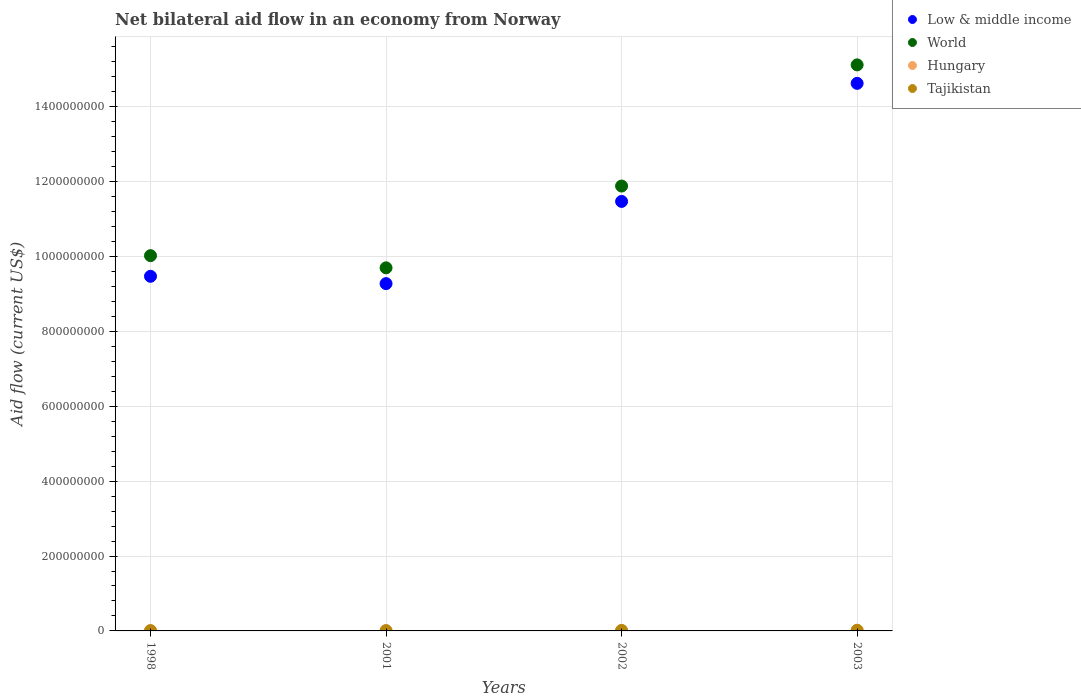How many different coloured dotlines are there?
Offer a terse response. 4. Is the number of dotlines equal to the number of legend labels?
Provide a short and direct response. Yes. Across all years, what is the maximum net bilateral aid flow in World?
Ensure brevity in your answer.  1.51e+09. Across all years, what is the minimum net bilateral aid flow in Low & middle income?
Give a very brief answer. 9.28e+08. In which year was the net bilateral aid flow in World maximum?
Provide a short and direct response. 2003. In which year was the net bilateral aid flow in Low & middle income minimum?
Your answer should be very brief. 2001. What is the total net bilateral aid flow in Low & middle income in the graph?
Ensure brevity in your answer.  4.48e+09. What is the difference between the net bilateral aid flow in Tajikistan in 2002 and that in 2003?
Keep it short and to the point. -4.90e+05. What is the difference between the net bilateral aid flow in Hungary in 1998 and the net bilateral aid flow in Low & middle income in 2001?
Provide a short and direct response. -9.27e+08. What is the average net bilateral aid flow in Tajikistan per year?
Give a very brief answer. 1.22e+06. In the year 2001, what is the difference between the net bilateral aid flow in World and net bilateral aid flow in Hungary?
Provide a short and direct response. 9.70e+08. What is the ratio of the net bilateral aid flow in Hungary in 1998 to that in 2003?
Provide a succinct answer. 0.49. Is the difference between the net bilateral aid flow in World in 1998 and 2003 greater than the difference between the net bilateral aid flow in Hungary in 1998 and 2003?
Your response must be concise. No. What is the difference between the highest and the lowest net bilateral aid flow in World?
Provide a short and direct response. 5.42e+08. Is it the case that in every year, the sum of the net bilateral aid flow in Hungary and net bilateral aid flow in Tajikistan  is greater than the sum of net bilateral aid flow in Low & middle income and net bilateral aid flow in World?
Offer a terse response. Yes. Is it the case that in every year, the sum of the net bilateral aid flow in Hungary and net bilateral aid flow in World  is greater than the net bilateral aid flow in Low & middle income?
Make the answer very short. Yes. Does the net bilateral aid flow in Tajikistan monotonically increase over the years?
Keep it short and to the point. No. How many years are there in the graph?
Make the answer very short. 4. Does the graph contain any zero values?
Ensure brevity in your answer.  No. Does the graph contain grids?
Ensure brevity in your answer.  Yes. Where does the legend appear in the graph?
Make the answer very short. Top right. How many legend labels are there?
Provide a short and direct response. 4. How are the legend labels stacked?
Your response must be concise. Vertical. What is the title of the graph?
Your answer should be compact. Net bilateral aid flow in an economy from Norway. Does "China" appear as one of the legend labels in the graph?
Ensure brevity in your answer.  No. What is the label or title of the Y-axis?
Provide a succinct answer. Aid flow (current US$). What is the Aid flow (current US$) in Low & middle income in 1998?
Provide a succinct answer. 9.47e+08. What is the Aid flow (current US$) of World in 1998?
Provide a succinct answer. 1.00e+09. What is the Aid flow (current US$) in Hungary in 1998?
Offer a very short reply. 1.70e+05. What is the Aid flow (current US$) in Tajikistan in 1998?
Provide a succinct answer. 8.30e+05. What is the Aid flow (current US$) of Low & middle income in 2001?
Ensure brevity in your answer.  9.28e+08. What is the Aid flow (current US$) of World in 2001?
Provide a short and direct response. 9.70e+08. What is the Aid flow (current US$) of Hungary in 2001?
Make the answer very short. 8.00e+04. What is the Aid flow (current US$) of Tajikistan in 2001?
Provide a succinct answer. 8.30e+05. What is the Aid flow (current US$) of Low & middle income in 2002?
Provide a succinct answer. 1.15e+09. What is the Aid flow (current US$) in World in 2002?
Offer a terse response. 1.19e+09. What is the Aid flow (current US$) of Hungary in 2002?
Provide a short and direct response. 2.80e+05. What is the Aid flow (current US$) in Tajikistan in 2002?
Your answer should be very brief. 1.36e+06. What is the Aid flow (current US$) of Low & middle income in 2003?
Provide a succinct answer. 1.46e+09. What is the Aid flow (current US$) of World in 2003?
Offer a very short reply. 1.51e+09. What is the Aid flow (current US$) in Tajikistan in 2003?
Ensure brevity in your answer.  1.85e+06. Across all years, what is the maximum Aid flow (current US$) in Low & middle income?
Give a very brief answer. 1.46e+09. Across all years, what is the maximum Aid flow (current US$) of World?
Your answer should be very brief. 1.51e+09. Across all years, what is the maximum Aid flow (current US$) in Tajikistan?
Provide a succinct answer. 1.85e+06. Across all years, what is the minimum Aid flow (current US$) of Low & middle income?
Offer a very short reply. 9.28e+08. Across all years, what is the minimum Aid flow (current US$) in World?
Offer a terse response. 9.70e+08. Across all years, what is the minimum Aid flow (current US$) in Tajikistan?
Your answer should be compact. 8.30e+05. What is the total Aid flow (current US$) of Low & middle income in the graph?
Offer a very short reply. 4.48e+09. What is the total Aid flow (current US$) in World in the graph?
Provide a succinct answer. 4.67e+09. What is the total Aid flow (current US$) in Hungary in the graph?
Give a very brief answer. 8.80e+05. What is the total Aid flow (current US$) in Tajikistan in the graph?
Ensure brevity in your answer.  4.87e+06. What is the difference between the Aid flow (current US$) in Low & middle income in 1998 and that in 2001?
Give a very brief answer. 1.95e+07. What is the difference between the Aid flow (current US$) of World in 1998 and that in 2001?
Your answer should be very brief. 3.25e+07. What is the difference between the Aid flow (current US$) in Hungary in 1998 and that in 2001?
Your answer should be very brief. 9.00e+04. What is the difference between the Aid flow (current US$) in Tajikistan in 1998 and that in 2001?
Your answer should be very brief. 0. What is the difference between the Aid flow (current US$) in Low & middle income in 1998 and that in 2002?
Offer a terse response. -2.00e+08. What is the difference between the Aid flow (current US$) in World in 1998 and that in 2002?
Ensure brevity in your answer.  -1.86e+08. What is the difference between the Aid flow (current US$) of Tajikistan in 1998 and that in 2002?
Make the answer very short. -5.30e+05. What is the difference between the Aid flow (current US$) in Low & middle income in 1998 and that in 2003?
Your response must be concise. -5.15e+08. What is the difference between the Aid flow (current US$) of World in 1998 and that in 2003?
Give a very brief answer. -5.10e+08. What is the difference between the Aid flow (current US$) in Hungary in 1998 and that in 2003?
Offer a terse response. -1.80e+05. What is the difference between the Aid flow (current US$) in Tajikistan in 1998 and that in 2003?
Offer a very short reply. -1.02e+06. What is the difference between the Aid flow (current US$) of Low & middle income in 2001 and that in 2002?
Your answer should be compact. -2.20e+08. What is the difference between the Aid flow (current US$) in World in 2001 and that in 2002?
Offer a very short reply. -2.18e+08. What is the difference between the Aid flow (current US$) of Tajikistan in 2001 and that in 2002?
Your answer should be compact. -5.30e+05. What is the difference between the Aid flow (current US$) in Low & middle income in 2001 and that in 2003?
Your answer should be very brief. -5.35e+08. What is the difference between the Aid flow (current US$) in World in 2001 and that in 2003?
Offer a terse response. -5.42e+08. What is the difference between the Aid flow (current US$) of Hungary in 2001 and that in 2003?
Your answer should be compact. -2.70e+05. What is the difference between the Aid flow (current US$) of Tajikistan in 2001 and that in 2003?
Your response must be concise. -1.02e+06. What is the difference between the Aid flow (current US$) of Low & middle income in 2002 and that in 2003?
Provide a succinct answer. -3.15e+08. What is the difference between the Aid flow (current US$) of World in 2002 and that in 2003?
Offer a very short reply. -3.24e+08. What is the difference between the Aid flow (current US$) of Tajikistan in 2002 and that in 2003?
Your response must be concise. -4.90e+05. What is the difference between the Aid flow (current US$) in Low & middle income in 1998 and the Aid flow (current US$) in World in 2001?
Your answer should be very brief. -2.26e+07. What is the difference between the Aid flow (current US$) of Low & middle income in 1998 and the Aid flow (current US$) of Hungary in 2001?
Keep it short and to the point. 9.47e+08. What is the difference between the Aid flow (current US$) in Low & middle income in 1998 and the Aid flow (current US$) in Tajikistan in 2001?
Keep it short and to the point. 9.46e+08. What is the difference between the Aid flow (current US$) of World in 1998 and the Aid flow (current US$) of Hungary in 2001?
Provide a short and direct response. 1.00e+09. What is the difference between the Aid flow (current US$) in World in 1998 and the Aid flow (current US$) in Tajikistan in 2001?
Your answer should be compact. 1.00e+09. What is the difference between the Aid flow (current US$) of Hungary in 1998 and the Aid flow (current US$) of Tajikistan in 2001?
Your response must be concise. -6.60e+05. What is the difference between the Aid flow (current US$) of Low & middle income in 1998 and the Aid flow (current US$) of World in 2002?
Offer a very short reply. -2.41e+08. What is the difference between the Aid flow (current US$) in Low & middle income in 1998 and the Aid flow (current US$) in Hungary in 2002?
Give a very brief answer. 9.47e+08. What is the difference between the Aid flow (current US$) in Low & middle income in 1998 and the Aid flow (current US$) in Tajikistan in 2002?
Provide a short and direct response. 9.46e+08. What is the difference between the Aid flow (current US$) of World in 1998 and the Aid flow (current US$) of Hungary in 2002?
Your response must be concise. 1.00e+09. What is the difference between the Aid flow (current US$) in World in 1998 and the Aid flow (current US$) in Tajikistan in 2002?
Your response must be concise. 1.00e+09. What is the difference between the Aid flow (current US$) of Hungary in 1998 and the Aid flow (current US$) of Tajikistan in 2002?
Make the answer very short. -1.19e+06. What is the difference between the Aid flow (current US$) in Low & middle income in 1998 and the Aid flow (current US$) in World in 2003?
Offer a very short reply. -5.65e+08. What is the difference between the Aid flow (current US$) in Low & middle income in 1998 and the Aid flow (current US$) in Hungary in 2003?
Offer a very short reply. 9.47e+08. What is the difference between the Aid flow (current US$) in Low & middle income in 1998 and the Aid flow (current US$) in Tajikistan in 2003?
Provide a succinct answer. 9.45e+08. What is the difference between the Aid flow (current US$) in World in 1998 and the Aid flow (current US$) in Hungary in 2003?
Make the answer very short. 1.00e+09. What is the difference between the Aid flow (current US$) of World in 1998 and the Aid flow (current US$) of Tajikistan in 2003?
Make the answer very short. 1.00e+09. What is the difference between the Aid flow (current US$) in Hungary in 1998 and the Aid flow (current US$) in Tajikistan in 2003?
Your answer should be very brief. -1.68e+06. What is the difference between the Aid flow (current US$) of Low & middle income in 2001 and the Aid flow (current US$) of World in 2002?
Offer a very short reply. -2.61e+08. What is the difference between the Aid flow (current US$) in Low & middle income in 2001 and the Aid flow (current US$) in Hungary in 2002?
Give a very brief answer. 9.27e+08. What is the difference between the Aid flow (current US$) of Low & middle income in 2001 and the Aid flow (current US$) of Tajikistan in 2002?
Ensure brevity in your answer.  9.26e+08. What is the difference between the Aid flow (current US$) in World in 2001 and the Aid flow (current US$) in Hungary in 2002?
Give a very brief answer. 9.70e+08. What is the difference between the Aid flow (current US$) in World in 2001 and the Aid flow (current US$) in Tajikistan in 2002?
Provide a short and direct response. 9.68e+08. What is the difference between the Aid flow (current US$) in Hungary in 2001 and the Aid flow (current US$) in Tajikistan in 2002?
Provide a short and direct response. -1.28e+06. What is the difference between the Aid flow (current US$) in Low & middle income in 2001 and the Aid flow (current US$) in World in 2003?
Give a very brief answer. -5.84e+08. What is the difference between the Aid flow (current US$) of Low & middle income in 2001 and the Aid flow (current US$) of Hungary in 2003?
Your answer should be very brief. 9.27e+08. What is the difference between the Aid flow (current US$) in Low & middle income in 2001 and the Aid flow (current US$) in Tajikistan in 2003?
Ensure brevity in your answer.  9.26e+08. What is the difference between the Aid flow (current US$) of World in 2001 and the Aid flow (current US$) of Hungary in 2003?
Offer a very short reply. 9.69e+08. What is the difference between the Aid flow (current US$) of World in 2001 and the Aid flow (current US$) of Tajikistan in 2003?
Make the answer very short. 9.68e+08. What is the difference between the Aid flow (current US$) of Hungary in 2001 and the Aid flow (current US$) of Tajikistan in 2003?
Your answer should be compact. -1.77e+06. What is the difference between the Aid flow (current US$) of Low & middle income in 2002 and the Aid flow (current US$) of World in 2003?
Make the answer very short. -3.65e+08. What is the difference between the Aid flow (current US$) of Low & middle income in 2002 and the Aid flow (current US$) of Hungary in 2003?
Make the answer very short. 1.15e+09. What is the difference between the Aid flow (current US$) of Low & middle income in 2002 and the Aid flow (current US$) of Tajikistan in 2003?
Your answer should be very brief. 1.15e+09. What is the difference between the Aid flow (current US$) of World in 2002 and the Aid flow (current US$) of Hungary in 2003?
Offer a very short reply. 1.19e+09. What is the difference between the Aid flow (current US$) of World in 2002 and the Aid flow (current US$) of Tajikistan in 2003?
Give a very brief answer. 1.19e+09. What is the difference between the Aid flow (current US$) of Hungary in 2002 and the Aid flow (current US$) of Tajikistan in 2003?
Your answer should be compact. -1.57e+06. What is the average Aid flow (current US$) in Low & middle income per year?
Offer a very short reply. 1.12e+09. What is the average Aid flow (current US$) of World per year?
Keep it short and to the point. 1.17e+09. What is the average Aid flow (current US$) of Tajikistan per year?
Provide a succinct answer. 1.22e+06. In the year 1998, what is the difference between the Aid flow (current US$) of Low & middle income and Aid flow (current US$) of World?
Your response must be concise. -5.51e+07. In the year 1998, what is the difference between the Aid flow (current US$) in Low & middle income and Aid flow (current US$) in Hungary?
Make the answer very short. 9.47e+08. In the year 1998, what is the difference between the Aid flow (current US$) in Low & middle income and Aid flow (current US$) in Tajikistan?
Your answer should be very brief. 9.46e+08. In the year 1998, what is the difference between the Aid flow (current US$) of World and Aid flow (current US$) of Hungary?
Give a very brief answer. 1.00e+09. In the year 1998, what is the difference between the Aid flow (current US$) of World and Aid flow (current US$) of Tajikistan?
Provide a short and direct response. 1.00e+09. In the year 1998, what is the difference between the Aid flow (current US$) of Hungary and Aid flow (current US$) of Tajikistan?
Keep it short and to the point. -6.60e+05. In the year 2001, what is the difference between the Aid flow (current US$) in Low & middle income and Aid flow (current US$) in World?
Your answer should be compact. -4.22e+07. In the year 2001, what is the difference between the Aid flow (current US$) of Low & middle income and Aid flow (current US$) of Hungary?
Offer a terse response. 9.28e+08. In the year 2001, what is the difference between the Aid flow (current US$) of Low & middle income and Aid flow (current US$) of Tajikistan?
Give a very brief answer. 9.27e+08. In the year 2001, what is the difference between the Aid flow (current US$) of World and Aid flow (current US$) of Hungary?
Keep it short and to the point. 9.70e+08. In the year 2001, what is the difference between the Aid flow (current US$) of World and Aid flow (current US$) of Tajikistan?
Offer a very short reply. 9.69e+08. In the year 2001, what is the difference between the Aid flow (current US$) in Hungary and Aid flow (current US$) in Tajikistan?
Make the answer very short. -7.50e+05. In the year 2002, what is the difference between the Aid flow (current US$) of Low & middle income and Aid flow (current US$) of World?
Provide a succinct answer. -4.11e+07. In the year 2002, what is the difference between the Aid flow (current US$) in Low & middle income and Aid flow (current US$) in Hungary?
Keep it short and to the point. 1.15e+09. In the year 2002, what is the difference between the Aid flow (current US$) of Low & middle income and Aid flow (current US$) of Tajikistan?
Your response must be concise. 1.15e+09. In the year 2002, what is the difference between the Aid flow (current US$) in World and Aid flow (current US$) in Hungary?
Offer a terse response. 1.19e+09. In the year 2002, what is the difference between the Aid flow (current US$) of World and Aid flow (current US$) of Tajikistan?
Keep it short and to the point. 1.19e+09. In the year 2002, what is the difference between the Aid flow (current US$) in Hungary and Aid flow (current US$) in Tajikistan?
Keep it short and to the point. -1.08e+06. In the year 2003, what is the difference between the Aid flow (current US$) of Low & middle income and Aid flow (current US$) of World?
Your response must be concise. -4.94e+07. In the year 2003, what is the difference between the Aid flow (current US$) of Low & middle income and Aid flow (current US$) of Hungary?
Give a very brief answer. 1.46e+09. In the year 2003, what is the difference between the Aid flow (current US$) of Low & middle income and Aid flow (current US$) of Tajikistan?
Ensure brevity in your answer.  1.46e+09. In the year 2003, what is the difference between the Aid flow (current US$) of World and Aid flow (current US$) of Hungary?
Your answer should be very brief. 1.51e+09. In the year 2003, what is the difference between the Aid flow (current US$) in World and Aid flow (current US$) in Tajikistan?
Make the answer very short. 1.51e+09. In the year 2003, what is the difference between the Aid flow (current US$) in Hungary and Aid flow (current US$) in Tajikistan?
Your answer should be very brief. -1.50e+06. What is the ratio of the Aid flow (current US$) of Low & middle income in 1998 to that in 2001?
Give a very brief answer. 1.02. What is the ratio of the Aid flow (current US$) in World in 1998 to that in 2001?
Ensure brevity in your answer.  1.03. What is the ratio of the Aid flow (current US$) of Hungary in 1998 to that in 2001?
Make the answer very short. 2.12. What is the ratio of the Aid flow (current US$) in Tajikistan in 1998 to that in 2001?
Make the answer very short. 1. What is the ratio of the Aid flow (current US$) in Low & middle income in 1998 to that in 2002?
Offer a terse response. 0.83. What is the ratio of the Aid flow (current US$) in World in 1998 to that in 2002?
Make the answer very short. 0.84. What is the ratio of the Aid flow (current US$) of Hungary in 1998 to that in 2002?
Provide a short and direct response. 0.61. What is the ratio of the Aid flow (current US$) in Tajikistan in 1998 to that in 2002?
Your response must be concise. 0.61. What is the ratio of the Aid flow (current US$) in Low & middle income in 1998 to that in 2003?
Give a very brief answer. 0.65. What is the ratio of the Aid flow (current US$) of World in 1998 to that in 2003?
Ensure brevity in your answer.  0.66. What is the ratio of the Aid flow (current US$) of Hungary in 1998 to that in 2003?
Make the answer very short. 0.49. What is the ratio of the Aid flow (current US$) in Tajikistan in 1998 to that in 2003?
Your answer should be compact. 0.45. What is the ratio of the Aid flow (current US$) in Low & middle income in 2001 to that in 2002?
Provide a succinct answer. 0.81. What is the ratio of the Aid flow (current US$) in World in 2001 to that in 2002?
Provide a succinct answer. 0.82. What is the ratio of the Aid flow (current US$) of Hungary in 2001 to that in 2002?
Ensure brevity in your answer.  0.29. What is the ratio of the Aid flow (current US$) of Tajikistan in 2001 to that in 2002?
Provide a short and direct response. 0.61. What is the ratio of the Aid flow (current US$) in Low & middle income in 2001 to that in 2003?
Provide a succinct answer. 0.63. What is the ratio of the Aid flow (current US$) of World in 2001 to that in 2003?
Your response must be concise. 0.64. What is the ratio of the Aid flow (current US$) in Hungary in 2001 to that in 2003?
Ensure brevity in your answer.  0.23. What is the ratio of the Aid flow (current US$) in Tajikistan in 2001 to that in 2003?
Provide a short and direct response. 0.45. What is the ratio of the Aid flow (current US$) of Low & middle income in 2002 to that in 2003?
Keep it short and to the point. 0.78. What is the ratio of the Aid flow (current US$) in World in 2002 to that in 2003?
Provide a succinct answer. 0.79. What is the ratio of the Aid flow (current US$) of Tajikistan in 2002 to that in 2003?
Ensure brevity in your answer.  0.74. What is the difference between the highest and the second highest Aid flow (current US$) in Low & middle income?
Ensure brevity in your answer.  3.15e+08. What is the difference between the highest and the second highest Aid flow (current US$) in World?
Make the answer very short. 3.24e+08. What is the difference between the highest and the second highest Aid flow (current US$) of Hungary?
Give a very brief answer. 7.00e+04. What is the difference between the highest and the second highest Aid flow (current US$) in Tajikistan?
Provide a succinct answer. 4.90e+05. What is the difference between the highest and the lowest Aid flow (current US$) in Low & middle income?
Your answer should be compact. 5.35e+08. What is the difference between the highest and the lowest Aid flow (current US$) of World?
Keep it short and to the point. 5.42e+08. What is the difference between the highest and the lowest Aid flow (current US$) of Tajikistan?
Your response must be concise. 1.02e+06. 